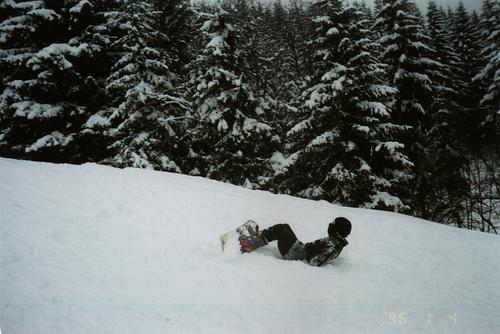Question: who is wearing a black hat?
Choices:
A. A snowboarder.
B. Man.
C. Woman.
D. Baby.
Answer with the letter. Answer: A Question: where is the man?
Choices:
A. Sleep.
B. Eating.
C. Laying in the snow.
D. Washing the car.
Answer with the letter. Answer: C Question: what color are the man's pants?
Choices:
A. Brown.
B. Tan.
C. Black.
D. White.
Answer with the letter. Answer: C Question: when was this photo taken?
Choices:
A. Morning.
B. Evening.
C. Afternoon.
D. During the daytime.
Answer with the letter. Answer: D Question: why is the person in the snow?
Choices:
A. He is snowboarding.
B. Playing.
C. Sports.
D. Enjoying weather.
Answer with the letter. Answer: A Question: where are the trees?
Choices:
A. Behind the house.
B. In the background behind the mountain.
C. Behind the building.
D. Foreground.
Answer with the letter. Answer: B 